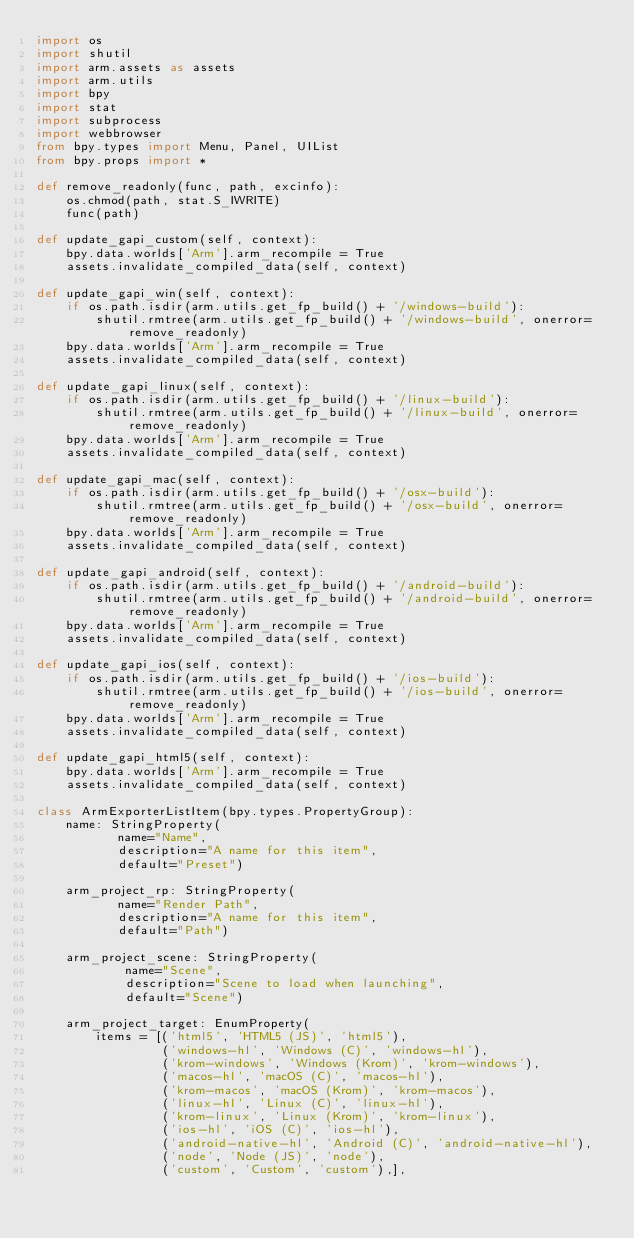<code> <loc_0><loc_0><loc_500><loc_500><_Python_>import os
import shutil
import arm.assets as assets
import arm.utils
import bpy
import stat
import subprocess
import webbrowser
from bpy.types import Menu, Panel, UIList
from bpy.props import *

def remove_readonly(func, path, excinfo):
    os.chmod(path, stat.S_IWRITE)
    func(path)

def update_gapi_custom(self, context):
    bpy.data.worlds['Arm'].arm_recompile = True
    assets.invalidate_compiled_data(self, context)

def update_gapi_win(self, context):
    if os.path.isdir(arm.utils.get_fp_build() + '/windows-build'):
        shutil.rmtree(arm.utils.get_fp_build() + '/windows-build', onerror=remove_readonly)
    bpy.data.worlds['Arm'].arm_recompile = True
    assets.invalidate_compiled_data(self, context)

def update_gapi_linux(self, context):
    if os.path.isdir(arm.utils.get_fp_build() + '/linux-build'):
        shutil.rmtree(arm.utils.get_fp_build() + '/linux-build', onerror=remove_readonly)
    bpy.data.worlds['Arm'].arm_recompile = True
    assets.invalidate_compiled_data(self, context)

def update_gapi_mac(self, context):
    if os.path.isdir(arm.utils.get_fp_build() + '/osx-build'):
        shutil.rmtree(arm.utils.get_fp_build() + '/osx-build', onerror=remove_readonly)
    bpy.data.worlds['Arm'].arm_recompile = True
    assets.invalidate_compiled_data(self, context)

def update_gapi_android(self, context):
    if os.path.isdir(arm.utils.get_fp_build() + '/android-build'):
        shutil.rmtree(arm.utils.get_fp_build() + '/android-build', onerror=remove_readonly)
    bpy.data.worlds['Arm'].arm_recompile = True
    assets.invalidate_compiled_data(self, context)

def update_gapi_ios(self, context):
    if os.path.isdir(arm.utils.get_fp_build() + '/ios-build'):
        shutil.rmtree(arm.utils.get_fp_build() + '/ios-build', onerror=remove_readonly)
    bpy.data.worlds['Arm'].arm_recompile = True
    assets.invalidate_compiled_data(self, context)

def update_gapi_html5(self, context):
    bpy.data.worlds['Arm'].arm_recompile = True
    assets.invalidate_compiled_data(self, context)

class ArmExporterListItem(bpy.types.PropertyGroup):
    name: StringProperty(
           name="Name",
           description="A name for this item",
           default="Preset")

    arm_project_rp: StringProperty(
           name="Render Path",
           description="A name for this item",
           default="Path")

    arm_project_scene: StringProperty(
            name="Scene",
            description="Scene to load when launching",
            default="Scene")

    arm_project_target: EnumProperty(
        items = [('html5', 'HTML5 (JS)', 'html5'),
                 ('windows-hl', 'Windows (C)', 'windows-hl'),
                 ('krom-windows', 'Windows (Krom)', 'krom-windows'),
                 ('macos-hl', 'macOS (C)', 'macos-hl'),
                 ('krom-macos', 'macOS (Krom)', 'krom-macos'),
                 ('linux-hl', 'Linux (C)', 'linux-hl'),
                 ('krom-linux', 'Linux (Krom)', 'krom-linux'),
                 ('ios-hl', 'iOS (C)', 'ios-hl'),
                 ('android-native-hl', 'Android (C)', 'android-native-hl'),
                 ('node', 'Node (JS)', 'node'),
                 ('custom', 'Custom', 'custom'),],</code> 